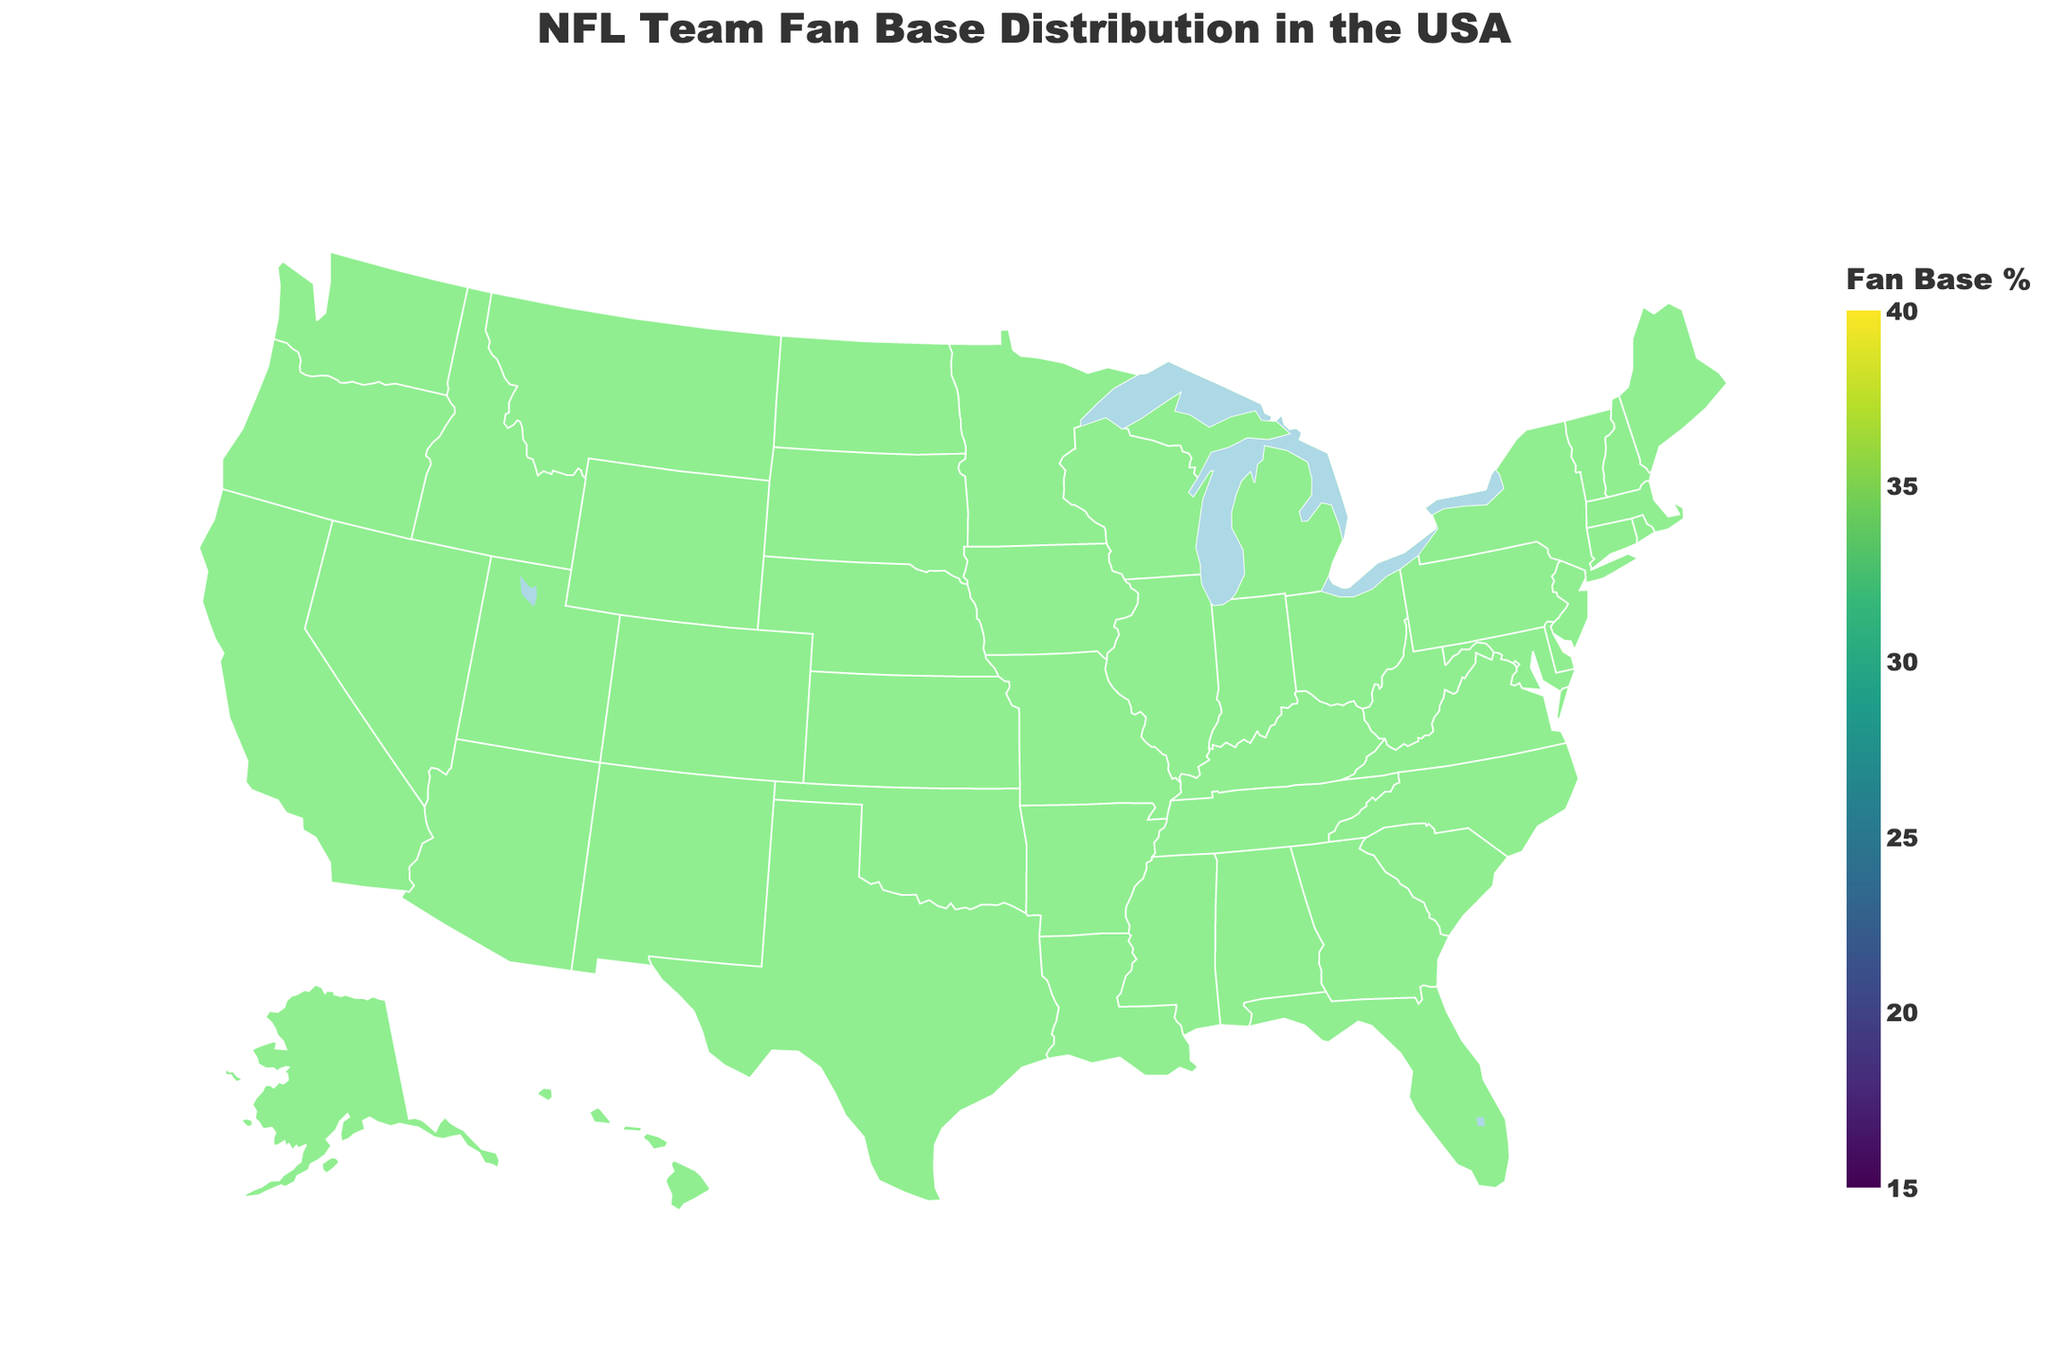Which NFL team has the highest percentage fan base, and in which state? Looking at the map, the state of Louisiana has the New Orleans Saints with the highest percentage of 34%.
Answer: New Orleans Saints, Louisiana What is the average fan base percentage of the teams shown in Texas, California, and Washington? The fan base percentages are: Texas (32%), California (18%), Washington (31%). Average = (32 + 18 + 31) / 3 = 27%
Answer: 27% Which states have fan bases with percentages greater than 30%? From the map, we can see that the states with fan bases above 30% are Texas (Cowboys), Washington (Seahawks), Missouri (Chiefs), and Louisiana (Saints).
Answer: Texas, Washington, Missouri, Louisiana Which team has the smallest fan base percentage? The map shows that the Arizona Cardinals have the smallest percentage fan base at 20%.
Answer: Arizona Cardinals How does the fan base percentage of the New York Giants compare to the Philadelphia Eagles? The map indicates the New York Giants have a 24% fan base in New York, whereas the Philadelphia Eagles have a 28% fan base in Pennsylvania. Therefore, the Eagles have a higher percentage.
Answer: Eagles have a higher percentage What’s the combined fan base percentage for the Green Bay Packers and Kansas City Chiefs? Green Bay Packers have a 35% fan base in Wisconsin, and Kansas City Chiefs have a 33% fan base in Missouri. Combined = 35 + 33 = 68%
Answer: 68% Which states have a fan base percentage below 25%? The map shows California (18% - Rams) and Arizona (20% - Cardinals) as the states with fan base percentages below 25%.
Answer: California, Arizona What is the percentage difference between the fan bases of the Cleveland Browns and the Detroit Lions? The Cleveland Browns have a 25% fan base in Ohio, and the Detroit Lions have a 23% fan base in Michigan. Difference = 25 - 23 = 2%
Answer: 2% Which team has almost the same fan base percentage as the Atlanta Falcons? Both the Chicago Bears and Tennessee Titans have a 26% fan base, which is close to the Atlanta Falcons' 27%.
Answer: Chicago Bears and Tennessee Titans 